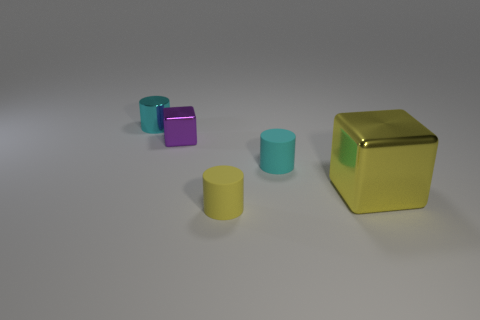There is a thing that is both in front of the cyan rubber thing and behind the tiny yellow rubber cylinder; what is its size?
Your answer should be very brief. Large. How many cylinders are either blue things or small cyan rubber objects?
Give a very brief answer. 1. What color is the shiny cylinder that is the same size as the purple metallic thing?
Give a very brief answer. Cyan. The other metallic object that is the same shape as the big yellow thing is what color?
Your answer should be very brief. Purple. How many things are either green cylinders or matte things in front of the large metal block?
Give a very brief answer. 1. Is the number of tiny metal blocks in front of the tiny purple shiny thing less than the number of cyan rubber balls?
Your response must be concise. No. How big is the rubber cylinder that is behind the rubber cylinder that is in front of the yellow object that is behind the tiny yellow matte thing?
Your answer should be compact. Small. There is a small object that is behind the cyan matte object and to the right of the small cyan metallic object; what is its color?
Ensure brevity in your answer.  Purple. What number of small objects are there?
Keep it short and to the point. 4. Is there any other thing that has the same size as the yellow shiny object?
Your answer should be compact. No. 